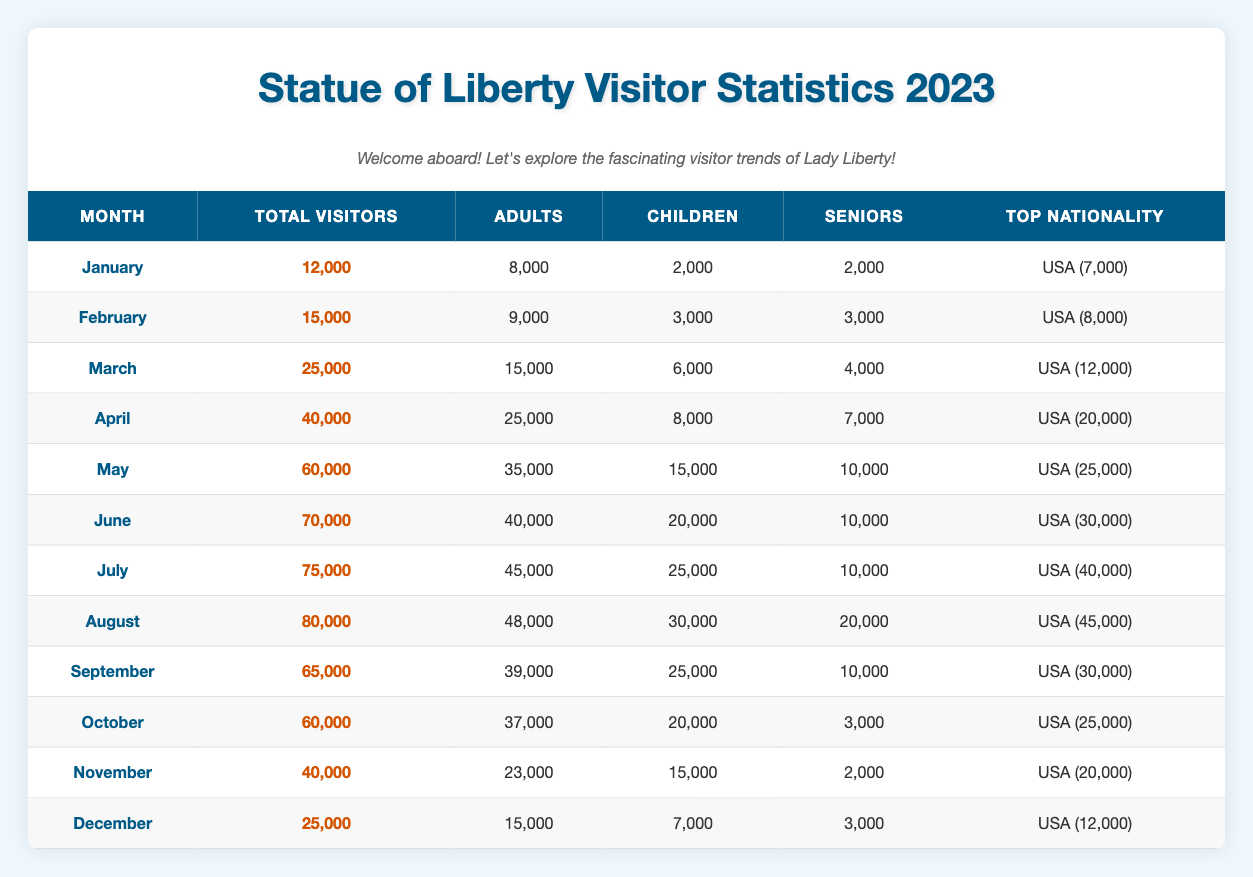What month had the highest number of total visitors? From the table, we can look at the "Total Visitors" column and identify the highest value. The highest value is 80,000 in August.
Answer: August How many children visited the Statue of Liberty in April? Referring to the table, in April, the "Children" count is 8,000.
Answer: 8,000 What is the total number of visitors from the USA from March to June? We will sum the "Total Visitors" from March (25,000), April (40,000), May (60,000), and June (70,000): 25000 + 40000 + 60000 + 70000 = 197,000 visitors from the USA.
Answer: 197,000 Did the number of seniors increase from January to December? In January, the count of seniors is 2,000, while in December it is 3,000. Thus, this indicates an increase in the number of seniors visiting from January to December.
Answer: Yes What percentage of total visitors in May were adults? In May, there were 60,000 total visitors, and 35,000 of them were adults. To find the percentage, we calculate (35,000 / 60,000) * 100 = 58.33%.
Answer: 58.33% 